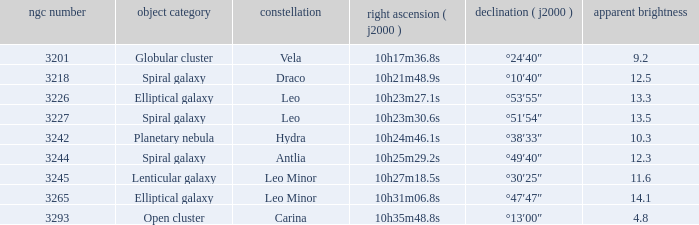What is the total of Apparent magnitudes for an NGC number larger than 3293? None. 